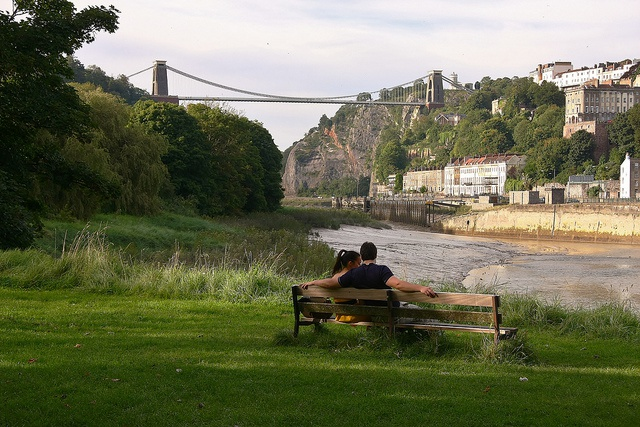Describe the objects in this image and their specific colors. I can see bench in white, black, olive, and gray tones, people in white, black, brown, and maroon tones, and people in white, black, maroon, gray, and tan tones in this image. 